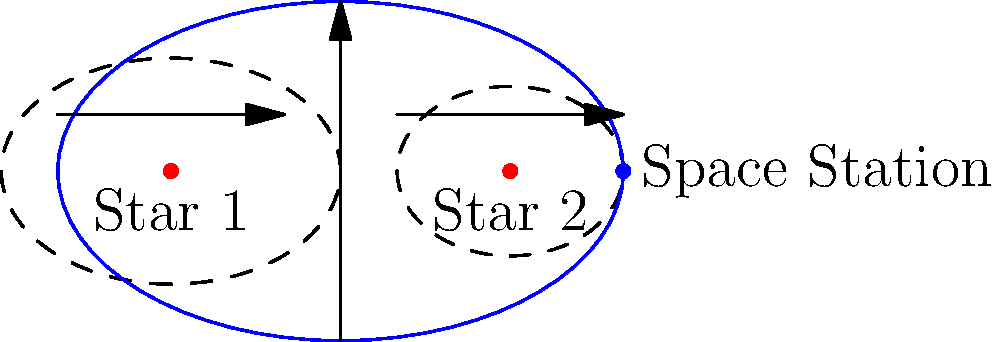Given the orbital paths of two stars in a binary system and an alien space station, predict the most likely shape and orientation of the space station's orbit. What physical principles govern this orbital configuration? To predict the orbit of the alien space station around a binary star system, we need to consider several key principles:

1. Center of Mass: In a binary star system, both stars orbit around their common center of mass. This point is located between the two stars, closer to the more massive star.

2. Gravitational Influence: The space station's orbit is influenced by the combined gravitational pull of both stars. This creates a more complex gravitational field compared to a single-star system.

3. Stability: For a stable orbit, the space station must maintain a distance that balances the gravitational forces from both stars. This often results in an orbit that encircles both stars.

4. Orbital Resonance: The station's orbit may fall into a resonance with the orbital period of the binary stars, which can help maintain stability.

5. Lagrange Points: In binary systems, there are regions of gravitational equilibrium called Lagrange points. The space station might orbit near one of these points for increased stability.

6. Elliptical Shape: Due to the varying gravitational influences, the orbit is likely to be elliptical rather than circular.

7. Orbital Plane: The station's orbital plane is likely to align with the plane of the binary star system to minimize perturbations.

Based on these principles, the most likely orbit for the space station would be:

- An elliptical path that encircles both stars
- Oriented in the same plane as the binary star orbit
- Possibly in resonance with the binary star orbital period
- Potentially positioned near a stable Lagrange point

The blue ellipse in the diagram represents this predicted orbit, encompassing both stars and aligned with their orbital plane.
Answer: Elliptical orbit encircling both stars, aligned with binary system's orbital plane 